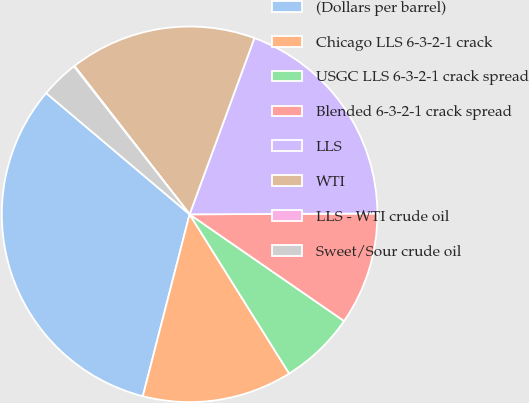Convert chart. <chart><loc_0><loc_0><loc_500><loc_500><pie_chart><fcel>(Dollars per barrel)<fcel>Chicago LLS 6-3-2-1 crack<fcel>USGC LLS 6-3-2-1 crack spread<fcel>Blended 6-3-2-1 crack spread<fcel>LLS<fcel>WTI<fcel>LLS - WTI crude oil<fcel>Sweet/Sour crude oil<nl><fcel>32.16%<fcel>12.9%<fcel>6.48%<fcel>9.69%<fcel>19.32%<fcel>16.11%<fcel>0.06%<fcel>3.27%<nl></chart> 